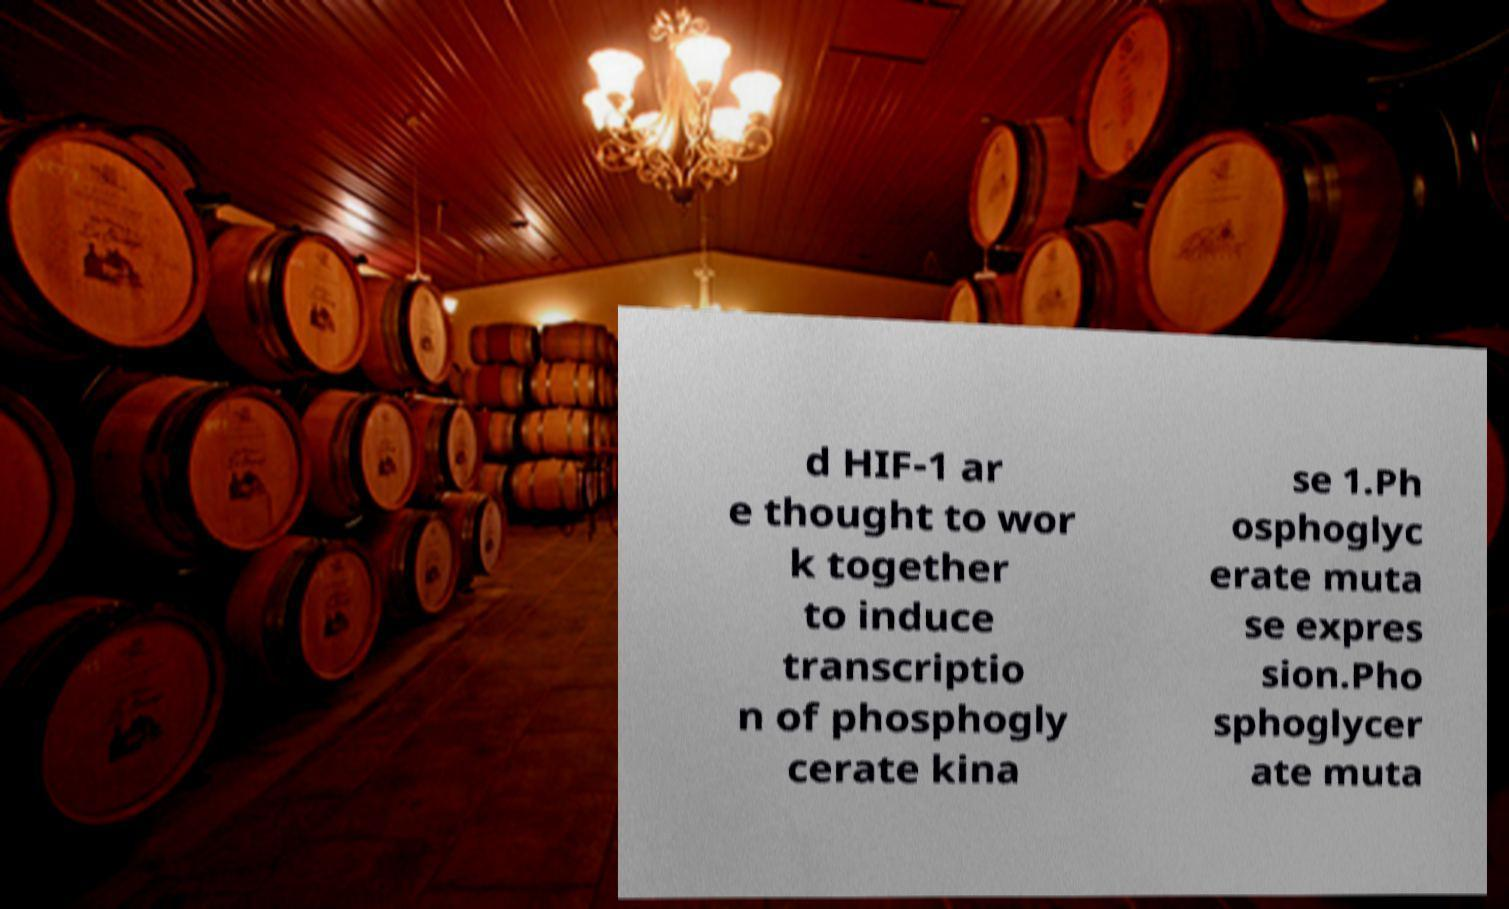Please read and relay the text visible in this image. What does it say? d HIF-1 ar e thought to wor k together to induce transcriptio n of phosphogly cerate kina se 1.Ph osphoglyc erate muta se expres sion.Pho sphoglycer ate muta 